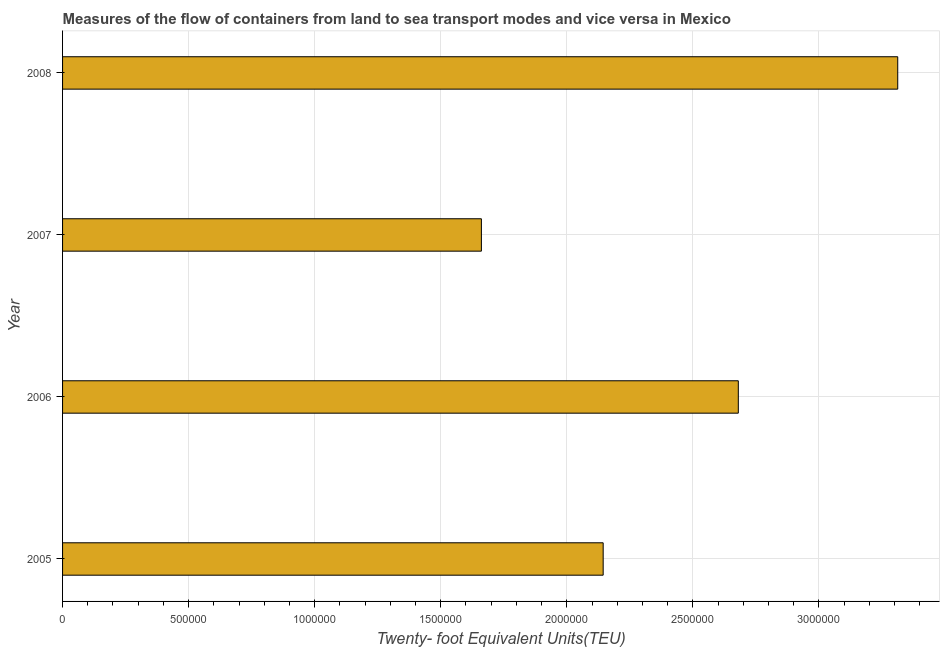Does the graph contain grids?
Make the answer very short. Yes. What is the title of the graph?
Offer a very short reply. Measures of the flow of containers from land to sea transport modes and vice versa in Mexico. What is the label or title of the X-axis?
Make the answer very short. Twenty- foot Equivalent Units(TEU). What is the label or title of the Y-axis?
Your answer should be compact. Year. What is the container port traffic in 2007?
Provide a succinct answer. 1.66e+06. Across all years, what is the maximum container port traffic?
Keep it short and to the point. 3.31e+06. Across all years, what is the minimum container port traffic?
Your response must be concise. 1.66e+06. What is the sum of the container port traffic?
Make the answer very short. 9.80e+06. What is the difference between the container port traffic in 2006 and 2007?
Provide a succinct answer. 1.02e+06. What is the average container port traffic per year?
Offer a very short reply. 2.45e+06. What is the median container port traffic?
Your answer should be very brief. 2.41e+06. In how many years, is the container port traffic greater than 800000 TEU?
Your response must be concise. 4. What is the ratio of the container port traffic in 2006 to that in 2007?
Give a very brief answer. 1.61. Is the difference between the container port traffic in 2005 and 2006 greater than the difference between any two years?
Provide a succinct answer. No. What is the difference between the highest and the second highest container port traffic?
Offer a very short reply. 6.32e+05. What is the difference between the highest and the lowest container port traffic?
Your response must be concise. 1.65e+06. How many bars are there?
Give a very brief answer. 4. Are all the bars in the graph horizontal?
Make the answer very short. Yes. How many years are there in the graph?
Provide a succinct answer. 4. Are the values on the major ticks of X-axis written in scientific E-notation?
Ensure brevity in your answer.  No. What is the Twenty- foot Equivalent Units(TEU) of 2005?
Make the answer very short. 2.14e+06. What is the Twenty- foot Equivalent Units(TEU) in 2006?
Provide a short and direct response. 2.68e+06. What is the Twenty- foot Equivalent Units(TEU) of 2007?
Keep it short and to the point. 1.66e+06. What is the Twenty- foot Equivalent Units(TEU) in 2008?
Your answer should be very brief. 3.31e+06. What is the difference between the Twenty- foot Equivalent Units(TEU) in 2005 and 2006?
Your answer should be very brief. -5.36e+05. What is the difference between the Twenty- foot Equivalent Units(TEU) in 2005 and 2007?
Your answer should be very brief. 4.83e+05. What is the difference between the Twenty- foot Equivalent Units(TEU) in 2005 and 2008?
Provide a succinct answer. -1.17e+06. What is the difference between the Twenty- foot Equivalent Units(TEU) in 2006 and 2007?
Provide a short and direct response. 1.02e+06. What is the difference between the Twenty- foot Equivalent Units(TEU) in 2006 and 2008?
Make the answer very short. -6.32e+05. What is the difference between the Twenty- foot Equivalent Units(TEU) in 2007 and 2008?
Ensure brevity in your answer.  -1.65e+06. What is the ratio of the Twenty- foot Equivalent Units(TEU) in 2005 to that in 2006?
Ensure brevity in your answer.  0.8. What is the ratio of the Twenty- foot Equivalent Units(TEU) in 2005 to that in 2007?
Ensure brevity in your answer.  1.29. What is the ratio of the Twenty- foot Equivalent Units(TEU) in 2005 to that in 2008?
Make the answer very short. 0.65. What is the ratio of the Twenty- foot Equivalent Units(TEU) in 2006 to that in 2007?
Your response must be concise. 1.61. What is the ratio of the Twenty- foot Equivalent Units(TEU) in 2006 to that in 2008?
Offer a very short reply. 0.81. What is the ratio of the Twenty- foot Equivalent Units(TEU) in 2007 to that in 2008?
Provide a short and direct response. 0.5. 